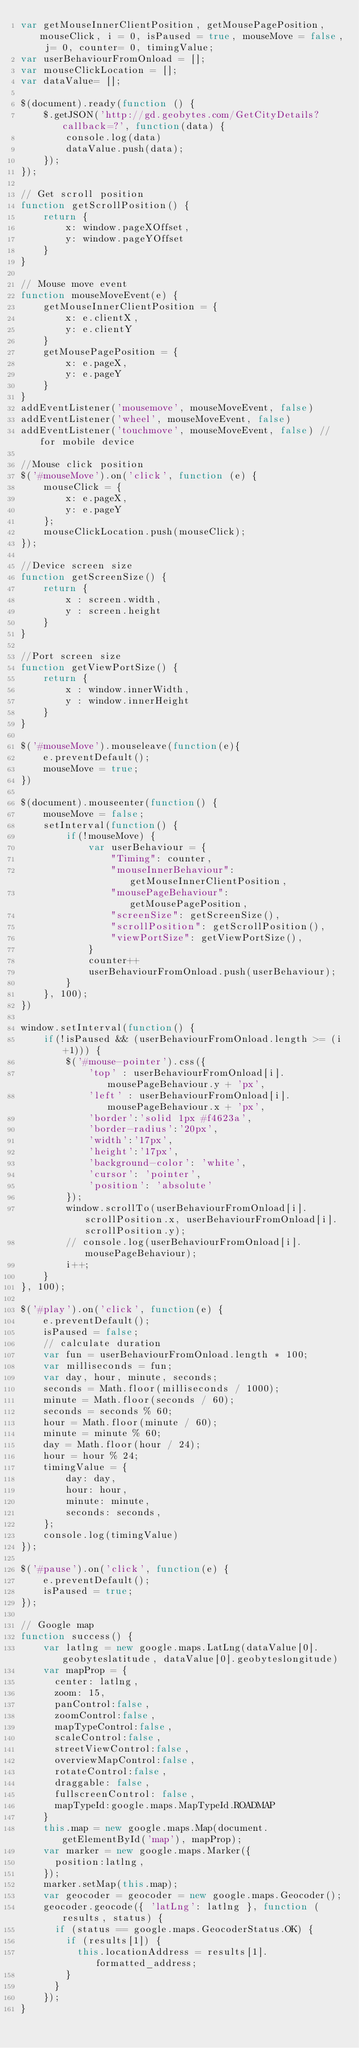<code> <loc_0><loc_0><loc_500><loc_500><_JavaScript_>var getMouseInnerClientPosition, getMousePagePosition, mouseClick, i = 0, isPaused = true, mouseMove = false, j= 0, counter= 0, timingValue;
var userBehaviourFromOnload = [];
var mouseClickLocation = [];
var dataValue= [];

$(document).ready(function () {
    $.getJSON('http://gd.geobytes.com/GetCityDetails?callback=?', function(data) {
        console.log(data)
        dataValue.push(data);
    });
});

// Get scroll position
function getScrollPosition() {
    return {
        x: window.pageXOffset,
        y: window.pageYOffset
    }
}

// Mouse move event
function mouseMoveEvent(e) {
    getMouseInnerClientPosition = {
        x: e.clientX,
        y: e.clientY
    }
    getMousePagePosition = {
        x: e.pageX,
        y: e.pageY
    }
}
addEventListener('mousemove', mouseMoveEvent, false)
addEventListener('wheel', mouseMoveEvent, false)
addEventListener('touchmove', mouseMoveEvent, false) //for mobile device

//Mouse click position
$('#mouseMove').on('click', function (e) {
    mouseClick = {
        x: e.pageX,
        y: e.pageY
    };
    mouseClickLocation.push(mouseClick);
});

//Device screen size
function getScreenSize() {
    return {
        x : screen.width,
        y : screen.height
    } 
}

//Port screen size
function getViewPortSize() {
    return {
        x : window.innerWidth,
        y : window.innerHeight
    }
}

$('#mouseMove').mouseleave(function(e){
    e.preventDefault();
    mouseMove = true;
})

$(document).mouseenter(function() {
    mouseMove = false;
    setInterval(function() {
        if(!mouseMove) {
            var userBehaviour = {
                "Timing": counter,
                "mouseInnerBehaviour": getMouseInnerClientPosition,
                "mousePageBehaviour": getMousePagePosition,
                "screenSize": getScreenSize(),
                "scrollPosition": getScrollPosition(),
                "viewPortSize": getViewPortSize(),
            }
            counter++
            userBehaviourFromOnload.push(userBehaviour);
        }
    }, 100);
})

window.setInterval(function() {
    if(!isPaused && (userBehaviourFromOnload.length >= (i+1))) {
        $('#mouse-pointer').css({
            'top' : userBehaviourFromOnload[i].mousePageBehaviour.y + 'px',
            'left' : userBehaviourFromOnload[i].mousePageBehaviour.x + 'px',
            'border':'solid 1px #f4623a',
            'border-radius':'20px',
            'width':'17px',
            'height':'17px',
            'background-color': 'white',
            'cursor': 'pointer',
            'position': 'absolute'
        });
        window.scrollTo(userBehaviourFromOnload[i].scrollPosition.x, userBehaviourFromOnload[i].scrollPosition.y);
        // console.log(userBehaviourFromOnload[i].mousePageBehaviour);
        i++;
    }
}, 100);

$('#play').on('click', function(e) {
    e.preventDefault();
    isPaused = false;
    // calculate duration
    var fun = userBehaviourFromOnload.length * 100;
    var milliseconds = fun;
    var day, hour, minute, seconds;
    seconds = Math.floor(milliseconds / 1000);
    minute = Math.floor(seconds / 60);
    seconds = seconds % 60;
    hour = Math.floor(minute / 60);
    minute = minute % 60;
    day = Math.floor(hour / 24);
    hour = hour % 24;
    timingValue = {
        day: day,
        hour: hour,
        minute: minute,
        seconds: seconds,
    };
    console.log(timingValue)
});

$('#pause').on('click', function(e) {
    e.preventDefault();
    isPaused = true;
});

// Google map
function success() {
    var latlng = new google.maps.LatLng(dataValue[0].geobyteslatitude, dataValue[0].geobyteslongitude)
    var mapProp = {
      center: latlng,
      zoom: 15,
      panControl:false,
      zoomControl:false,
      mapTypeControl:false,
      scaleControl:false,
      streetViewControl:false,
      overviewMapControl:false,
      rotateControl:false,
      draggable: false,
      fullscreenControl: false,
      mapTypeId:google.maps.MapTypeId.ROADMAP
    }
    this.map = new google.maps.Map(document.getElementById('map'), mapProp);
    var marker = new google.maps.Marker({
      position:latlng,
    });
    marker.setMap(this.map);
    var geocoder = geocoder = new google.maps.Geocoder();
    geocoder.geocode({ 'latLng': latlng }, function (results, status) {
      if (status == google.maps.GeocoderStatus.OK) {
        if (results[1]) {
          this.locationAddress = results[1].formatted_address;
        }
      }
    });
}</code> 